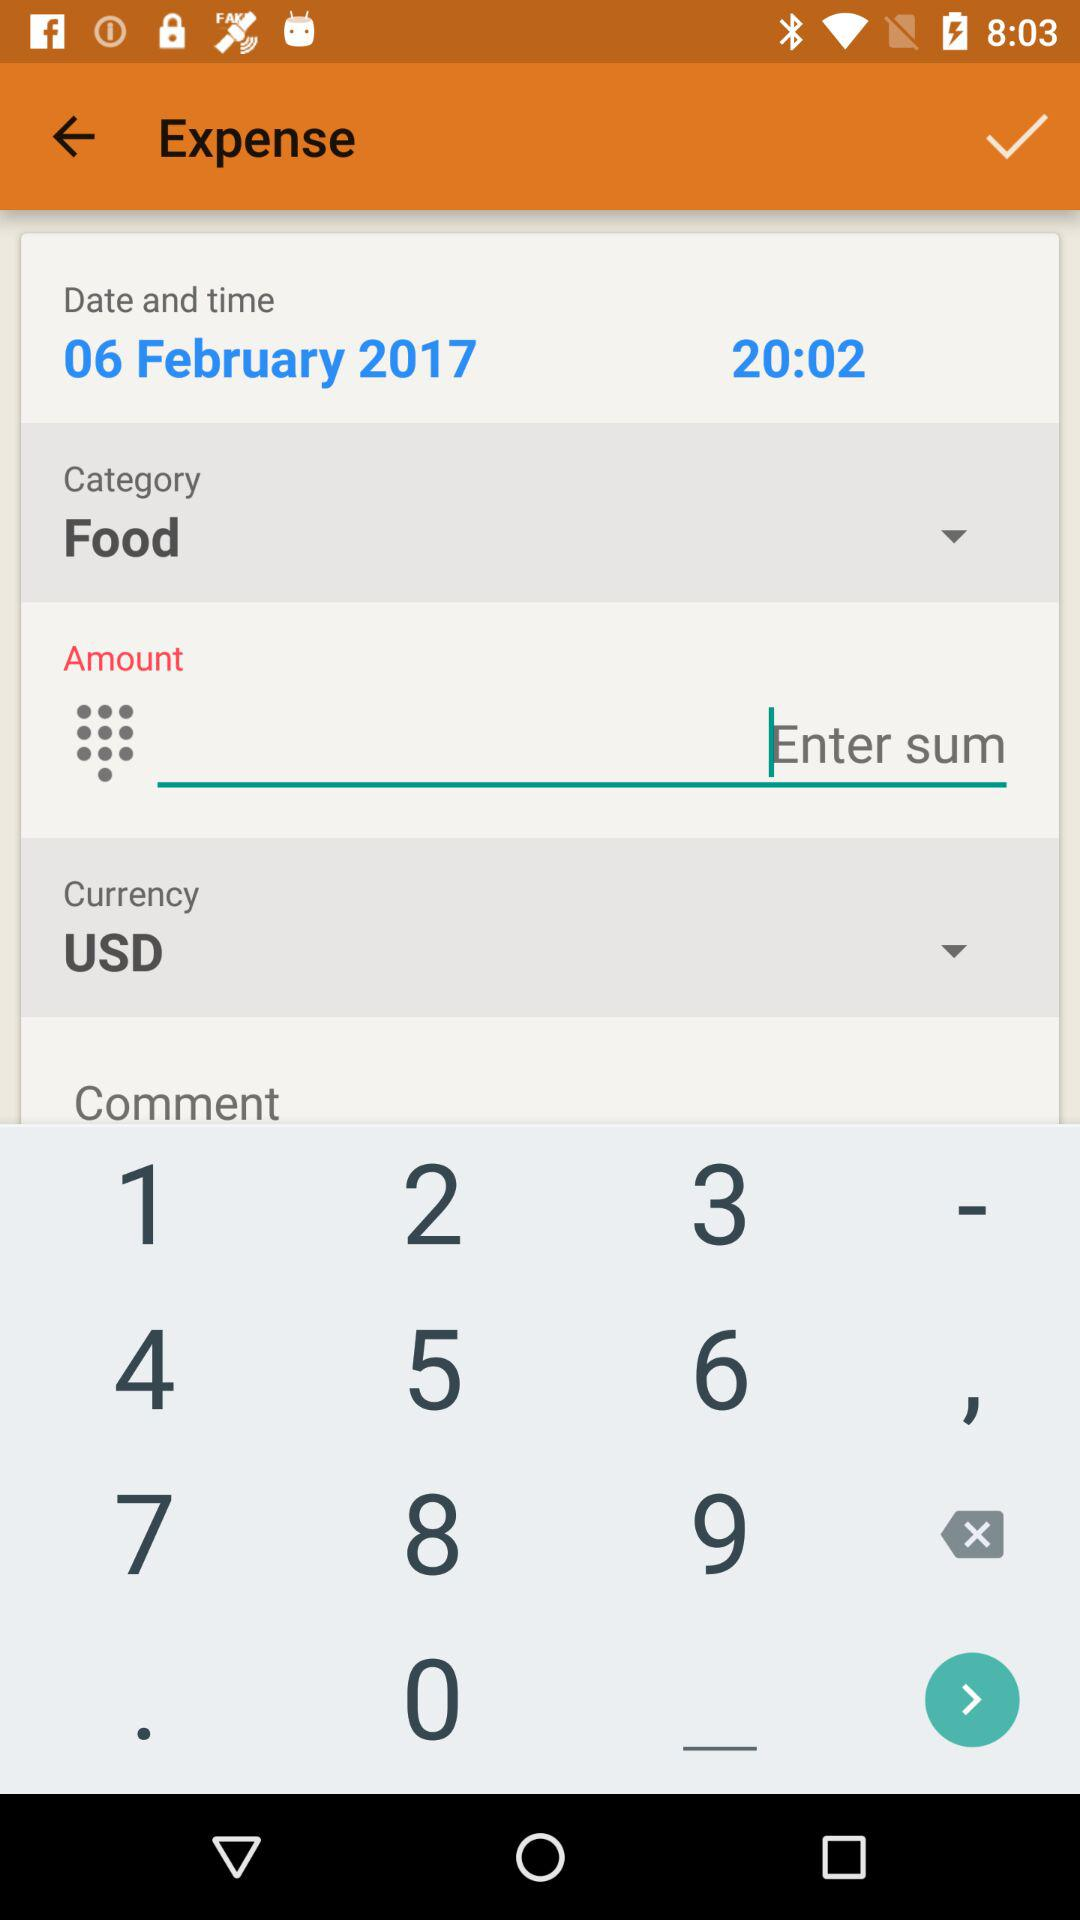What is the currency of the expense?
Answer the question using a single word or phrase. USD 